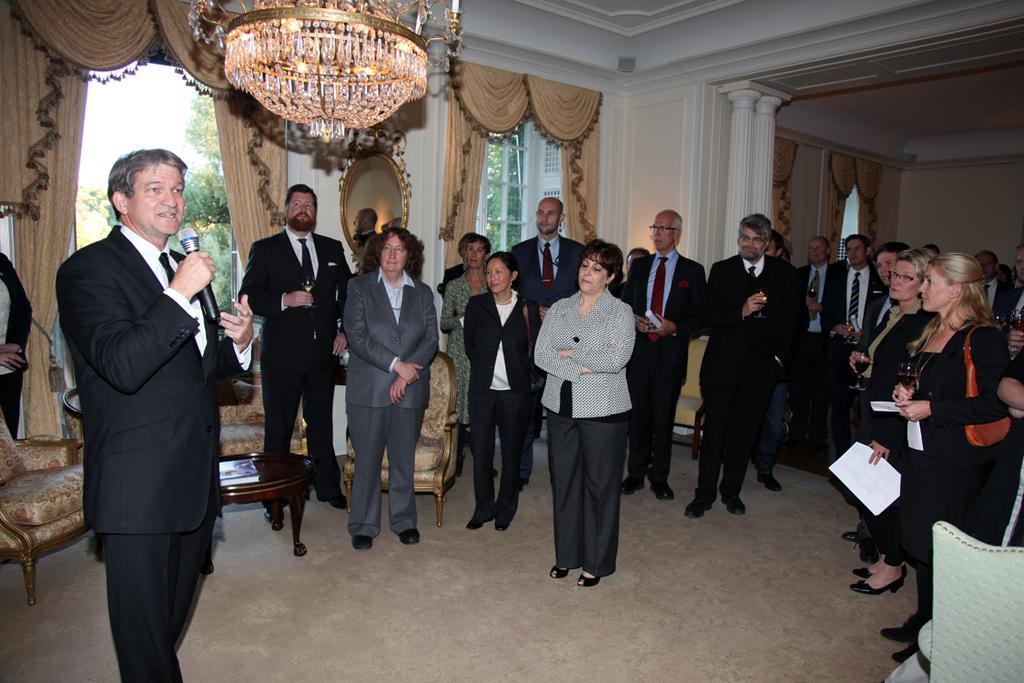Describe this image in one or two sentences. In this picture I can see there is a person is standing on to left and is speaking in the micro phone and there are a group of people standing, the men and woman are wearing black blazers and dresses. There is a light attached to the ceiling and there is a door and a window with curtains and there are trees visible from the door and the sky is clear. 